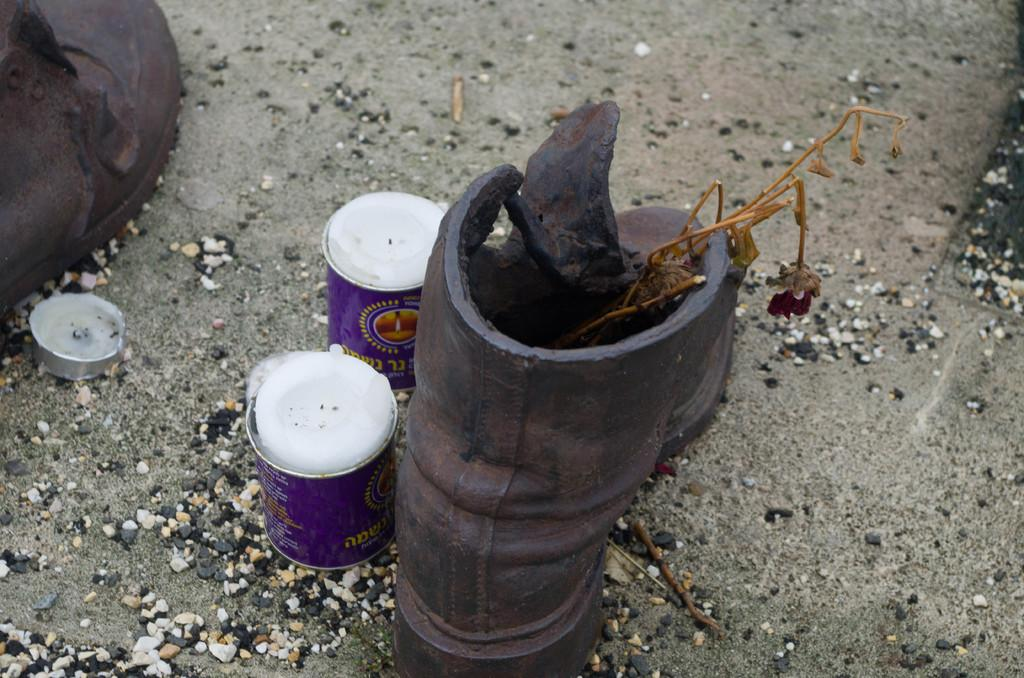What type of footwear is visible in the image? There are boots in the image. What type of lighting source is present in the image? There are candles in the image. What type of natural material is present in the image? There are stones in the image. What other objects can be seen on the ground in the image? There are other objects on the ground in the image. What type of prose is being recited by the cows in the image? There are no cows present in the image, and therefore no prose is being recited. What form do the stones take in the image? The form of the stones cannot be determined from the image alone, as they are not described in detail. 